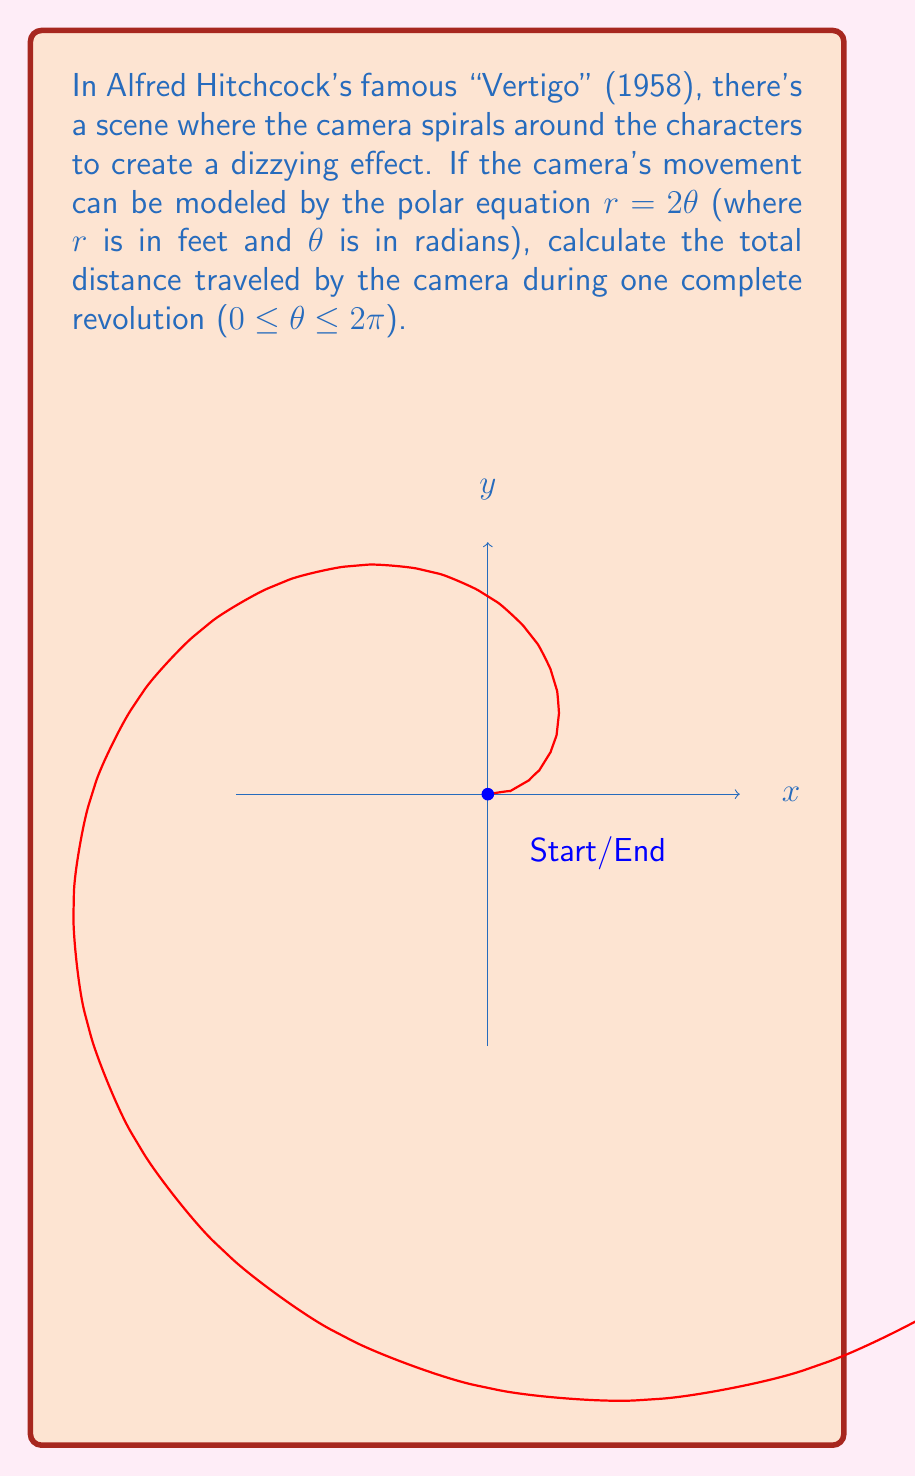Solve this math problem. To solve this problem, we need to use the formula for the arc length of a polar curve. The steps are as follows:

1) The formula for the arc length of a polar curve from $\theta = a$ to $\theta = b$ is:

   $$L = \int_a^b \sqrt{r^2 + \left(\frac{dr}{d\theta}\right)^2} d\theta$$

2) In our case, $r = 2\theta$, so $\frac{dr}{d\theta} = 2$

3) Substituting these into the formula:

   $$L = \int_0^{2\pi} \sqrt{(2\theta)^2 + 2^2} d\theta$$

4) Simplify inside the square root:

   $$L = \int_0^{2\pi} \sqrt{4\theta^2 + 4} d\theta$$

5) Factor out the 4:

   $$L = 2\int_0^{2\pi} \sqrt{\theta^2 + 1} d\theta$$

6) This integral doesn't have an elementary antiderivative. We need to use the hyperbolic functions. The antiderivative is:

   $$\frac{1}{2}[\theta\sqrt{\theta^2+1} + \ln(\theta + \sqrt{\theta^2+1})]$$

7) Evaluate this from 0 to 2π:

   $$L = [\theta\sqrt{\theta^2+1} + \ln(\theta + \sqrt{\theta^2+1})]_0^{2\pi}$$

8) Plugging in the limits:

   $$L = [2\pi\sqrt{(2\pi)^2+1} + \ln(2\pi + \sqrt{(2\pi)^2+1})] - [0 + \ln(0 + 1)]$$

9) Simplify:

   $$L = 2\pi\sqrt{4\pi^2+1} + \ln(2\pi + \sqrt{4\pi^2+1})$$

This is the exact answer. For a numerical approximation, we can use a calculator:

   $$L \approx 39.9786 \text{ feet}$$
Answer: $2\pi\sqrt{4\pi^2+1} + \ln(2\pi + \sqrt{4\pi^2+1})$ feet 